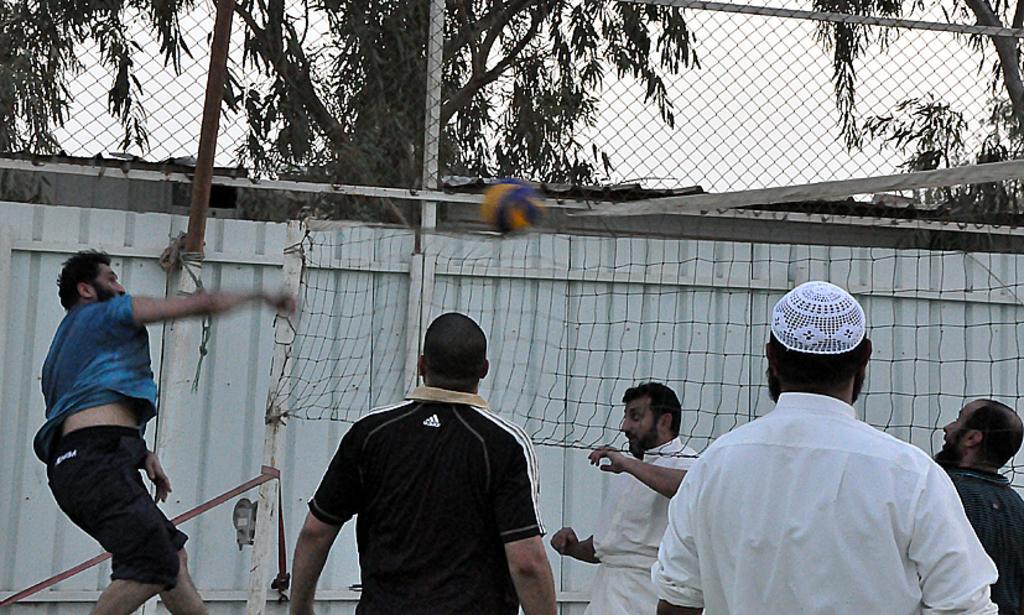Please provide a concise description of this image. There are few people playing volleyball. Person on the right is wearing a cap. There is a net and a ball. In the back there is a fencing. Also there is a net above that. In the back there are trees and sky. 